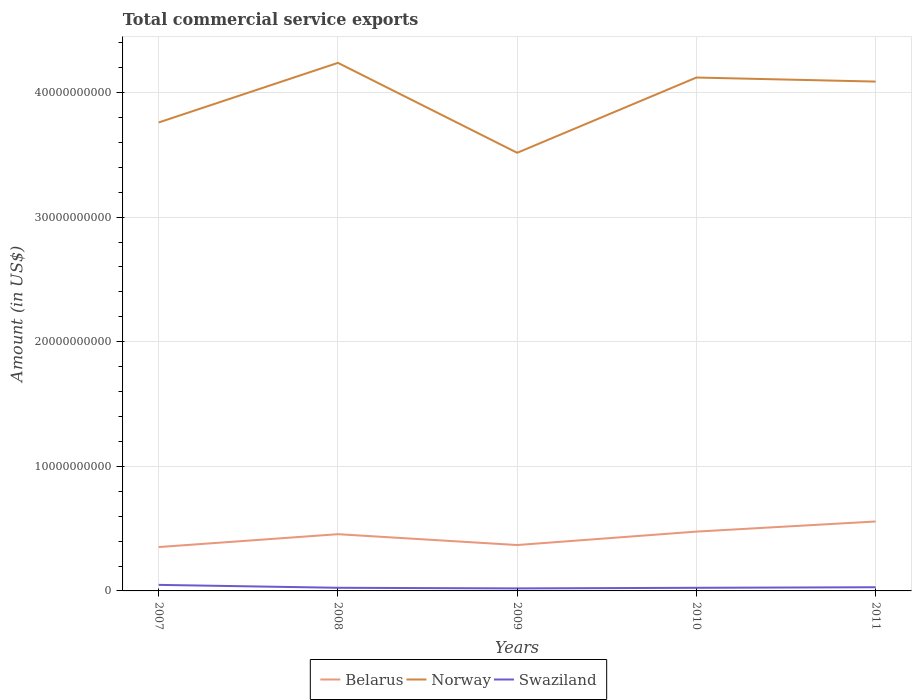Is the number of lines equal to the number of legend labels?
Your answer should be very brief. Yes. Across all years, what is the maximum total commercial service exports in Swaziland?
Give a very brief answer. 2.02e+08. In which year was the total commercial service exports in Swaziland maximum?
Offer a terse response. 2009. What is the total total commercial service exports in Swaziland in the graph?
Provide a succinct answer. 2.84e+08. What is the difference between the highest and the second highest total commercial service exports in Norway?
Provide a short and direct response. 7.22e+09. Is the total commercial service exports in Swaziland strictly greater than the total commercial service exports in Belarus over the years?
Provide a succinct answer. Yes. Are the values on the major ticks of Y-axis written in scientific E-notation?
Make the answer very short. No. Does the graph contain grids?
Give a very brief answer. Yes. Where does the legend appear in the graph?
Provide a short and direct response. Bottom center. How are the legend labels stacked?
Your response must be concise. Horizontal. What is the title of the graph?
Your answer should be very brief. Total commercial service exports. What is the label or title of the X-axis?
Your response must be concise. Years. What is the Amount (in US$) in Belarus in 2007?
Make the answer very short. 3.52e+09. What is the Amount (in US$) of Norway in 2007?
Provide a short and direct response. 3.76e+1. What is the Amount (in US$) of Swaziland in 2007?
Keep it short and to the point. 4.86e+08. What is the Amount (in US$) in Belarus in 2008?
Ensure brevity in your answer.  4.55e+09. What is the Amount (in US$) in Norway in 2008?
Provide a short and direct response. 4.24e+1. What is the Amount (in US$) of Swaziland in 2008?
Ensure brevity in your answer.  2.52e+08. What is the Amount (in US$) of Belarus in 2009?
Offer a terse response. 3.68e+09. What is the Amount (in US$) in Norway in 2009?
Your answer should be very brief. 3.52e+1. What is the Amount (in US$) in Swaziland in 2009?
Make the answer very short. 2.02e+08. What is the Amount (in US$) of Belarus in 2010?
Your answer should be very brief. 4.76e+09. What is the Amount (in US$) of Norway in 2010?
Provide a succinct answer. 4.12e+1. What is the Amount (in US$) in Swaziland in 2010?
Provide a short and direct response. 2.50e+08. What is the Amount (in US$) of Belarus in 2011?
Your answer should be very brief. 5.57e+09. What is the Amount (in US$) in Norway in 2011?
Provide a short and direct response. 4.09e+1. What is the Amount (in US$) of Swaziland in 2011?
Your answer should be very brief. 2.96e+08. Across all years, what is the maximum Amount (in US$) in Belarus?
Your answer should be compact. 5.57e+09. Across all years, what is the maximum Amount (in US$) in Norway?
Offer a terse response. 4.24e+1. Across all years, what is the maximum Amount (in US$) in Swaziland?
Ensure brevity in your answer.  4.86e+08. Across all years, what is the minimum Amount (in US$) in Belarus?
Your answer should be very brief. 3.52e+09. Across all years, what is the minimum Amount (in US$) in Norway?
Your answer should be compact. 3.52e+1. Across all years, what is the minimum Amount (in US$) in Swaziland?
Your answer should be compact. 2.02e+08. What is the total Amount (in US$) of Belarus in the graph?
Your response must be concise. 2.21e+1. What is the total Amount (in US$) of Norway in the graph?
Keep it short and to the point. 1.97e+11. What is the total Amount (in US$) of Swaziland in the graph?
Your response must be concise. 1.49e+09. What is the difference between the Amount (in US$) of Belarus in 2007 and that in 2008?
Your answer should be compact. -1.03e+09. What is the difference between the Amount (in US$) in Norway in 2007 and that in 2008?
Your response must be concise. -4.78e+09. What is the difference between the Amount (in US$) of Swaziland in 2007 and that in 2008?
Give a very brief answer. 2.34e+08. What is the difference between the Amount (in US$) in Belarus in 2007 and that in 2009?
Give a very brief answer. -1.62e+08. What is the difference between the Amount (in US$) of Norway in 2007 and that in 2009?
Provide a succinct answer. 2.43e+09. What is the difference between the Amount (in US$) of Swaziland in 2007 and that in 2009?
Your answer should be very brief. 2.84e+08. What is the difference between the Amount (in US$) in Belarus in 2007 and that in 2010?
Your answer should be very brief. -1.24e+09. What is the difference between the Amount (in US$) in Norway in 2007 and that in 2010?
Your answer should be very brief. -3.61e+09. What is the difference between the Amount (in US$) in Swaziland in 2007 and that in 2010?
Offer a very short reply. 2.36e+08. What is the difference between the Amount (in US$) of Belarus in 2007 and that in 2011?
Your response must be concise. -2.05e+09. What is the difference between the Amount (in US$) of Norway in 2007 and that in 2011?
Your answer should be compact. -3.28e+09. What is the difference between the Amount (in US$) of Swaziland in 2007 and that in 2011?
Provide a short and direct response. 1.90e+08. What is the difference between the Amount (in US$) in Belarus in 2008 and that in 2009?
Make the answer very short. 8.70e+08. What is the difference between the Amount (in US$) of Norway in 2008 and that in 2009?
Offer a terse response. 7.22e+09. What is the difference between the Amount (in US$) of Swaziland in 2008 and that in 2009?
Make the answer very short. 5.07e+07. What is the difference between the Amount (in US$) in Belarus in 2008 and that in 2010?
Give a very brief answer. -2.08e+08. What is the difference between the Amount (in US$) in Norway in 2008 and that in 2010?
Your answer should be very brief. 1.18e+09. What is the difference between the Amount (in US$) in Swaziland in 2008 and that in 2010?
Make the answer very short. 1.93e+06. What is the difference between the Amount (in US$) in Belarus in 2008 and that in 2011?
Your answer should be compact. -1.02e+09. What is the difference between the Amount (in US$) of Norway in 2008 and that in 2011?
Make the answer very short. 1.50e+09. What is the difference between the Amount (in US$) in Swaziland in 2008 and that in 2011?
Give a very brief answer. -4.35e+07. What is the difference between the Amount (in US$) of Belarus in 2009 and that in 2010?
Give a very brief answer. -1.08e+09. What is the difference between the Amount (in US$) of Norway in 2009 and that in 2010?
Offer a terse response. -6.04e+09. What is the difference between the Amount (in US$) in Swaziland in 2009 and that in 2010?
Ensure brevity in your answer.  -4.88e+07. What is the difference between the Amount (in US$) of Belarus in 2009 and that in 2011?
Give a very brief answer. -1.89e+09. What is the difference between the Amount (in US$) of Norway in 2009 and that in 2011?
Keep it short and to the point. -5.72e+09. What is the difference between the Amount (in US$) in Swaziland in 2009 and that in 2011?
Give a very brief answer. -9.42e+07. What is the difference between the Amount (in US$) in Belarus in 2010 and that in 2011?
Provide a succinct answer. -8.12e+08. What is the difference between the Amount (in US$) of Norway in 2010 and that in 2011?
Offer a very short reply. 3.24e+08. What is the difference between the Amount (in US$) of Swaziland in 2010 and that in 2011?
Make the answer very short. -4.54e+07. What is the difference between the Amount (in US$) of Belarus in 2007 and the Amount (in US$) of Norway in 2008?
Your answer should be very brief. -3.89e+1. What is the difference between the Amount (in US$) in Belarus in 2007 and the Amount (in US$) in Swaziland in 2008?
Make the answer very short. 3.27e+09. What is the difference between the Amount (in US$) of Norway in 2007 and the Amount (in US$) of Swaziland in 2008?
Give a very brief answer. 3.73e+1. What is the difference between the Amount (in US$) of Belarus in 2007 and the Amount (in US$) of Norway in 2009?
Your answer should be very brief. -3.16e+1. What is the difference between the Amount (in US$) in Belarus in 2007 and the Amount (in US$) in Swaziland in 2009?
Offer a very short reply. 3.32e+09. What is the difference between the Amount (in US$) of Norway in 2007 and the Amount (in US$) of Swaziland in 2009?
Ensure brevity in your answer.  3.74e+1. What is the difference between the Amount (in US$) of Belarus in 2007 and the Amount (in US$) of Norway in 2010?
Ensure brevity in your answer.  -3.77e+1. What is the difference between the Amount (in US$) in Belarus in 2007 and the Amount (in US$) in Swaziland in 2010?
Your answer should be compact. 3.27e+09. What is the difference between the Amount (in US$) in Norway in 2007 and the Amount (in US$) in Swaziland in 2010?
Your response must be concise. 3.73e+1. What is the difference between the Amount (in US$) of Belarus in 2007 and the Amount (in US$) of Norway in 2011?
Your response must be concise. -3.74e+1. What is the difference between the Amount (in US$) in Belarus in 2007 and the Amount (in US$) in Swaziland in 2011?
Make the answer very short. 3.23e+09. What is the difference between the Amount (in US$) in Norway in 2007 and the Amount (in US$) in Swaziland in 2011?
Provide a succinct answer. 3.73e+1. What is the difference between the Amount (in US$) of Belarus in 2008 and the Amount (in US$) of Norway in 2009?
Make the answer very short. -3.06e+1. What is the difference between the Amount (in US$) in Belarus in 2008 and the Amount (in US$) in Swaziland in 2009?
Your answer should be very brief. 4.35e+09. What is the difference between the Amount (in US$) in Norway in 2008 and the Amount (in US$) in Swaziland in 2009?
Your answer should be very brief. 4.22e+1. What is the difference between the Amount (in US$) in Belarus in 2008 and the Amount (in US$) in Norway in 2010?
Provide a short and direct response. -3.67e+1. What is the difference between the Amount (in US$) of Belarus in 2008 and the Amount (in US$) of Swaziland in 2010?
Your response must be concise. 4.30e+09. What is the difference between the Amount (in US$) of Norway in 2008 and the Amount (in US$) of Swaziland in 2010?
Your answer should be very brief. 4.21e+1. What is the difference between the Amount (in US$) in Belarus in 2008 and the Amount (in US$) in Norway in 2011?
Provide a short and direct response. -3.63e+1. What is the difference between the Amount (in US$) of Belarus in 2008 and the Amount (in US$) of Swaziland in 2011?
Keep it short and to the point. 4.26e+09. What is the difference between the Amount (in US$) in Norway in 2008 and the Amount (in US$) in Swaziland in 2011?
Keep it short and to the point. 4.21e+1. What is the difference between the Amount (in US$) of Belarus in 2009 and the Amount (in US$) of Norway in 2010?
Ensure brevity in your answer.  -3.75e+1. What is the difference between the Amount (in US$) in Belarus in 2009 and the Amount (in US$) in Swaziland in 2010?
Your response must be concise. 3.43e+09. What is the difference between the Amount (in US$) of Norway in 2009 and the Amount (in US$) of Swaziland in 2010?
Provide a short and direct response. 3.49e+1. What is the difference between the Amount (in US$) of Belarus in 2009 and the Amount (in US$) of Norway in 2011?
Make the answer very short. -3.72e+1. What is the difference between the Amount (in US$) of Belarus in 2009 and the Amount (in US$) of Swaziland in 2011?
Offer a terse response. 3.39e+09. What is the difference between the Amount (in US$) in Norway in 2009 and the Amount (in US$) in Swaziland in 2011?
Your answer should be compact. 3.49e+1. What is the difference between the Amount (in US$) in Belarus in 2010 and the Amount (in US$) in Norway in 2011?
Offer a very short reply. -3.61e+1. What is the difference between the Amount (in US$) of Belarus in 2010 and the Amount (in US$) of Swaziland in 2011?
Your answer should be compact. 4.47e+09. What is the difference between the Amount (in US$) in Norway in 2010 and the Amount (in US$) in Swaziland in 2011?
Offer a very short reply. 4.09e+1. What is the average Amount (in US$) in Belarus per year?
Ensure brevity in your answer.  4.42e+09. What is the average Amount (in US$) of Norway per year?
Give a very brief answer. 3.94e+1. What is the average Amount (in US$) of Swaziland per year?
Ensure brevity in your answer.  2.97e+08. In the year 2007, what is the difference between the Amount (in US$) in Belarus and Amount (in US$) in Norway?
Your answer should be compact. -3.41e+1. In the year 2007, what is the difference between the Amount (in US$) in Belarus and Amount (in US$) in Swaziland?
Provide a short and direct response. 3.04e+09. In the year 2007, what is the difference between the Amount (in US$) in Norway and Amount (in US$) in Swaziland?
Your answer should be compact. 3.71e+1. In the year 2008, what is the difference between the Amount (in US$) in Belarus and Amount (in US$) in Norway?
Provide a succinct answer. -3.78e+1. In the year 2008, what is the difference between the Amount (in US$) in Belarus and Amount (in US$) in Swaziland?
Offer a very short reply. 4.30e+09. In the year 2008, what is the difference between the Amount (in US$) of Norway and Amount (in US$) of Swaziland?
Make the answer very short. 4.21e+1. In the year 2009, what is the difference between the Amount (in US$) of Belarus and Amount (in US$) of Norway?
Your answer should be very brief. -3.15e+1. In the year 2009, what is the difference between the Amount (in US$) of Belarus and Amount (in US$) of Swaziland?
Your response must be concise. 3.48e+09. In the year 2009, what is the difference between the Amount (in US$) of Norway and Amount (in US$) of Swaziland?
Make the answer very short. 3.50e+1. In the year 2010, what is the difference between the Amount (in US$) in Belarus and Amount (in US$) in Norway?
Make the answer very short. -3.64e+1. In the year 2010, what is the difference between the Amount (in US$) in Belarus and Amount (in US$) in Swaziland?
Your response must be concise. 4.51e+09. In the year 2010, what is the difference between the Amount (in US$) of Norway and Amount (in US$) of Swaziland?
Provide a succinct answer. 4.10e+1. In the year 2011, what is the difference between the Amount (in US$) of Belarus and Amount (in US$) of Norway?
Provide a succinct answer. -3.53e+1. In the year 2011, what is the difference between the Amount (in US$) of Belarus and Amount (in US$) of Swaziland?
Offer a very short reply. 5.28e+09. In the year 2011, what is the difference between the Amount (in US$) in Norway and Amount (in US$) in Swaziland?
Provide a succinct answer. 4.06e+1. What is the ratio of the Amount (in US$) of Belarus in 2007 to that in 2008?
Your response must be concise. 0.77. What is the ratio of the Amount (in US$) in Norway in 2007 to that in 2008?
Your answer should be very brief. 0.89. What is the ratio of the Amount (in US$) of Swaziland in 2007 to that in 2008?
Provide a short and direct response. 1.93. What is the ratio of the Amount (in US$) in Belarus in 2007 to that in 2009?
Your answer should be very brief. 0.96. What is the ratio of the Amount (in US$) of Norway in 2007 to that in 2009?
Ensure brevity in your answer.  1.07. What is the ratio of the Amount (in US$) in Swaziland in 2007 to that in 2009?
Offer a terse response. 2.41. What is the ratio of the Amount (in US$) in Belarus in 2007 to that in 2010?
Ensure brevity in your answer.  0.74. What is the ratio of the Amount (in US$) of Norway in 2007 to that in 2010?
Provide a succinct answer. 0.91. What is the ratio of the Amount (in US$) of Swaziland in 2007 to that in 2010?
Your response must be concise. 1.94. What is the ratio of the Amount (in US$) of Belarus in 2007 to that in 2011?
Your response must be concise. 0.63. What is the ratio of the Amount (in US$) in Norway in 2007 to that in 2011?
Offer a terse response. 0.92. What is the ratio of the Amount (in US$) of Swaziland in 2007 to that in 2011?
Your response must be concise. 1.64. What is the ratio of the Amount (in US$) of Belarus in 2008 to that in 2009?
Your answer should be compact. 1.24. What is the ratio of the Amount (in US$) of Norway in 2008 to that in 2009?
Your answer should be compact. 1.21. What is the ratio of the Amount (in US$) in Swaziland in 2008 to that in 2009?
Give a very brief answer. 1.25. What is the ratio of the Amount (in US$) of Belarus in 2008 to that in 2010?
Keep it short and to the point. 0.96. What is the ratio of the Amount (in US$) in Norway in 2008 to that in 2010?
Your answer should be compact. 1.03. What is the ratio of the Amount (in US$) of Swaziland in 2008 to that in 2010?
Your answer should be compact. 1.01. What is the ratio of the Amount (in US$) in Belarus in 2008 to that in 2011?
Your answer should be compact. 0.82. What is the ratio of the Amount (in US$) in Norway in 2008 to that in 2011?
Your answer should be very brief. 1.04. What is the ratio of the Amount (in US$) in Swaziland in 2008 to that in 2011?
Your answer should be compact. 0.85. What is the ratio of the Amount (in US$) in Belarus in 2009 to that in 2010?
Give a very brief answer. 0.77. What is the ratio of the Amount (in US$) in Norway in 2009 to that in 2010?
Offer a very short reply. 0.85. What is the ratio of the Amount (in US$) of Swaziland in 2009 to that in 2010?
Your response must be concise. 0.81. What is the ratio of the Amount (in US$) of Belarus in 2009 to that in 2011?
Your answer should be very brief. 0.66. What is the ratio of the Amount (in US$) of Norway in 2009 to that in 2011?
Ensure brevity in your answer.  0.86. What is the ratio of the Amount (in US$) of Swaziland in 2009 to that in 2011?
Your answer should be compact. 0.68. What is the ratio of the Amount (in US$) in Belarus in 2010 to that in 2011?
Your answer should be compact. 0.85. What is the ratio of the Amount (in US$) in Norway in 2010 to that in 2011?
Offer a very short reply. 1.01. What is the ratio of the Amount (in US$) of Swaziland in 2010 to that in 2011?
Your answer should be very brief. 0.85. What is the difference between the highest and the second highest Amount (in US$) of Belarus?
Give a very brief answer. 8.12e+08. What is the difference between the highest and the second highest Amount (in US$) of Norway?
Offer a terse response. 1.18e+09. What is the difference between the highest and the second highest Amount (in US$) of Swaziland?
Your answer should be very brief. 1.90e+08. What is the difference between the highest and the lowest Amount (in US$) of Belarus?
Your answer should be compact. 2.05e+09. What is the difference between the highest and the lowest Amount (in US$) in Norway?
Make the answer very short. 7.22e+09. What is the difference between the highest and the lowest Amount (in US$) of Swaziland?
Provide a succinct answer. 2.84e+08. 